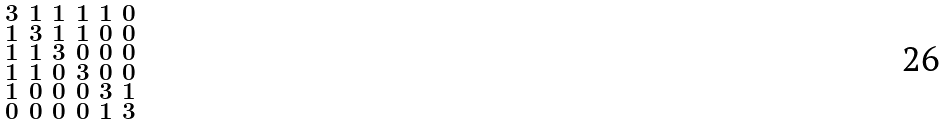<formula> <loc_0><loc_0><loc_500><loc_500>\begin{smallmatrix} 3 & 1 & 1 & 1 & 1 & 0 \\ 1 & 3 & 1 & 1 & 0 & 0 \\ 1 & 1 & 3 & 0 & 0 & 0 \\ 1 & 1 & 0 & 3 & 0 & 0 \\ 1 & 0 & 0 & 0 & 3 & 1 \\ 0 & 0 & 0 & 0 & 1 & 3 \end{smallmatrix}</formula> 